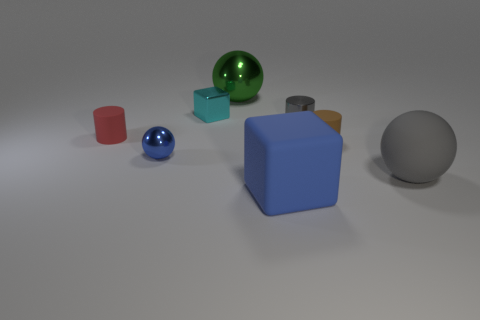Is the sphere that is behind the small brown cylinder made of the same material as the small block?
Your response must be concise. Yes. How many things are either shiny things in front of the cyan block or tiny things?
Your answer should be compact. 5. What color is the cylinder that is the same material as the small red object?
Your response must be concise. Brown. Is there a matte ball that has the same size as the red matte thing?
Your answer should be compact. No. Does the ball left of the tiny block have the same color as the rubber block?
Ensure brevity in your answer.  Yes. There is a large thing that is left of the gray ball and right of the large green ball; what is its color?
Your answer should be very brief. Blue. The cyan object that is the same size as the gray cylinder is what shape?
Your response must be concise. Cube. Are there any red things that have the same shape as the gray metal thing?
Make the answer very short. Yes. Do the sphere that is on the left side of the green shiny ball and the green metallic ball have the same size?
Provide a succinct answer. No. How big is the cylinder that is in front of the gray cylinder and on the right side of the green shiny ball?
Ensure brevity in your answer.  Small. 